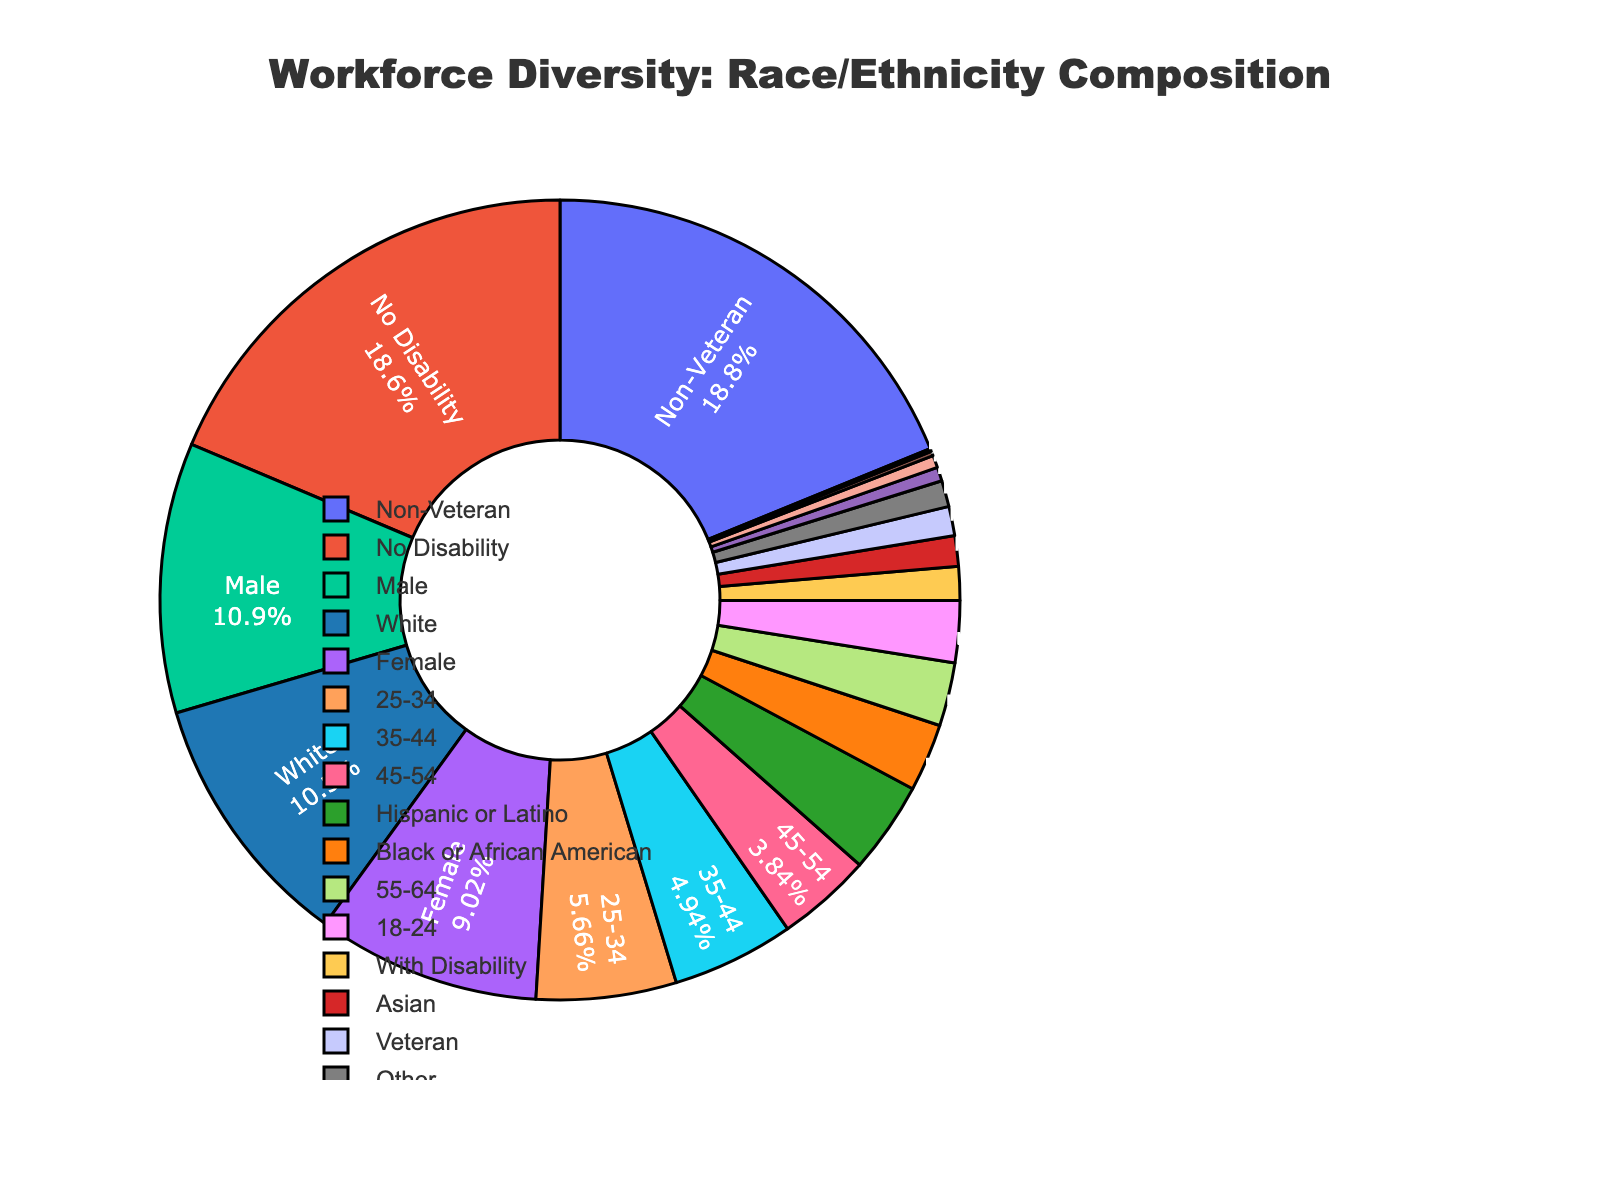What's the largest racial/ethnic group in the workforce diversity composition? The largest section of the pie chart is labeled "White". This section comprises 52.3% of the pie, making it the largest group.
Answer: White How much larger is the percentage of Hispanics or Latinos compared to Asians in the workforce? Hispanics or Latinos represent 18.5%, while Asians represent 6.2%. The difference is 18.5% - 6.2% = 12.3%.
Answer: 12.3% What's the combined percentage of American Indian or Alaska Native and Native Hawaiian or Other Pacific Islander? The percentage for American Indian or Alaska Native is 0.9%, and for Native Hawaiian or Other Pacific Islander, it is 0.3%. The combined percentage is 0.9% + 0.3% = 1.2%.
Answer: 1.2% Are there more Black or African American individuals or those listed as "Other"? Black or African Americans make up 13.7%, while "Other" makes up 5.3%. 13.7% is greater than 5.3%.
Answer: Black or African American What proportion of the workforce is represented by groups with less than 10% each? Groups with less than 10% are Asian (6.2%), Two or More Races (2.8%), American Indian or Alaska Native (0.9%), Native Hawaiian or Other Pacific Islander (0.3%), and Other (5.3%). Summing these gives 6.2% + 2.8% + 0.9% + 0.3% + 5.3% = 15.5%.
Answer: 15.5% Which groups have a percentage closest to the average percentage of all the groups in the chart? To find the average, sum all percentages and divide by the number of groups: (52.3% + 13.7% + 18.5% + 6.2% + 2.8% + 0.9% + 0.3% + 5.3%) / 8 = 100% / 8 = 12.5%. The closest group is the 13.7% of Black or African American.
Answer: Black or African American Considering the top three largest groups, what is their combined percentage? The top three groups are White (52.3%), Hispanic or Latino (18.5%), and Black or African American (13.7%). Their combined percentage is 52.3% + 18.5% + 13.7% = 84.5%.
Answer: 84.5% Which color in the figure represents Two or More Races? The color associated with Two or More Races is a shade, but specific hues are not visible in text. By comparing to other known colors in the pie chart, Two or More Races may be identified.
Answer: Purple (assuming familiar colors typically used in such charts) How does the size of the “White” segment compare visually to the “Asian” segment? The "White" segment is more than half the pie chart, dominating visually, while the "Asian" segment is much smaller, representing just 6.2% and visually taking up only a small fraction of the chart.
Answer: Much larger 